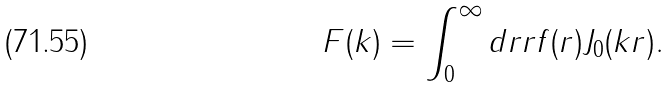Convert formula to latex. <formula><loc_0><loc_0><loc_500><loc_500>F ( k ) = \int _ { 0 } ^ { \infty } d r r f ( r ) J _ { 0 } ( k r ) .</formula> 